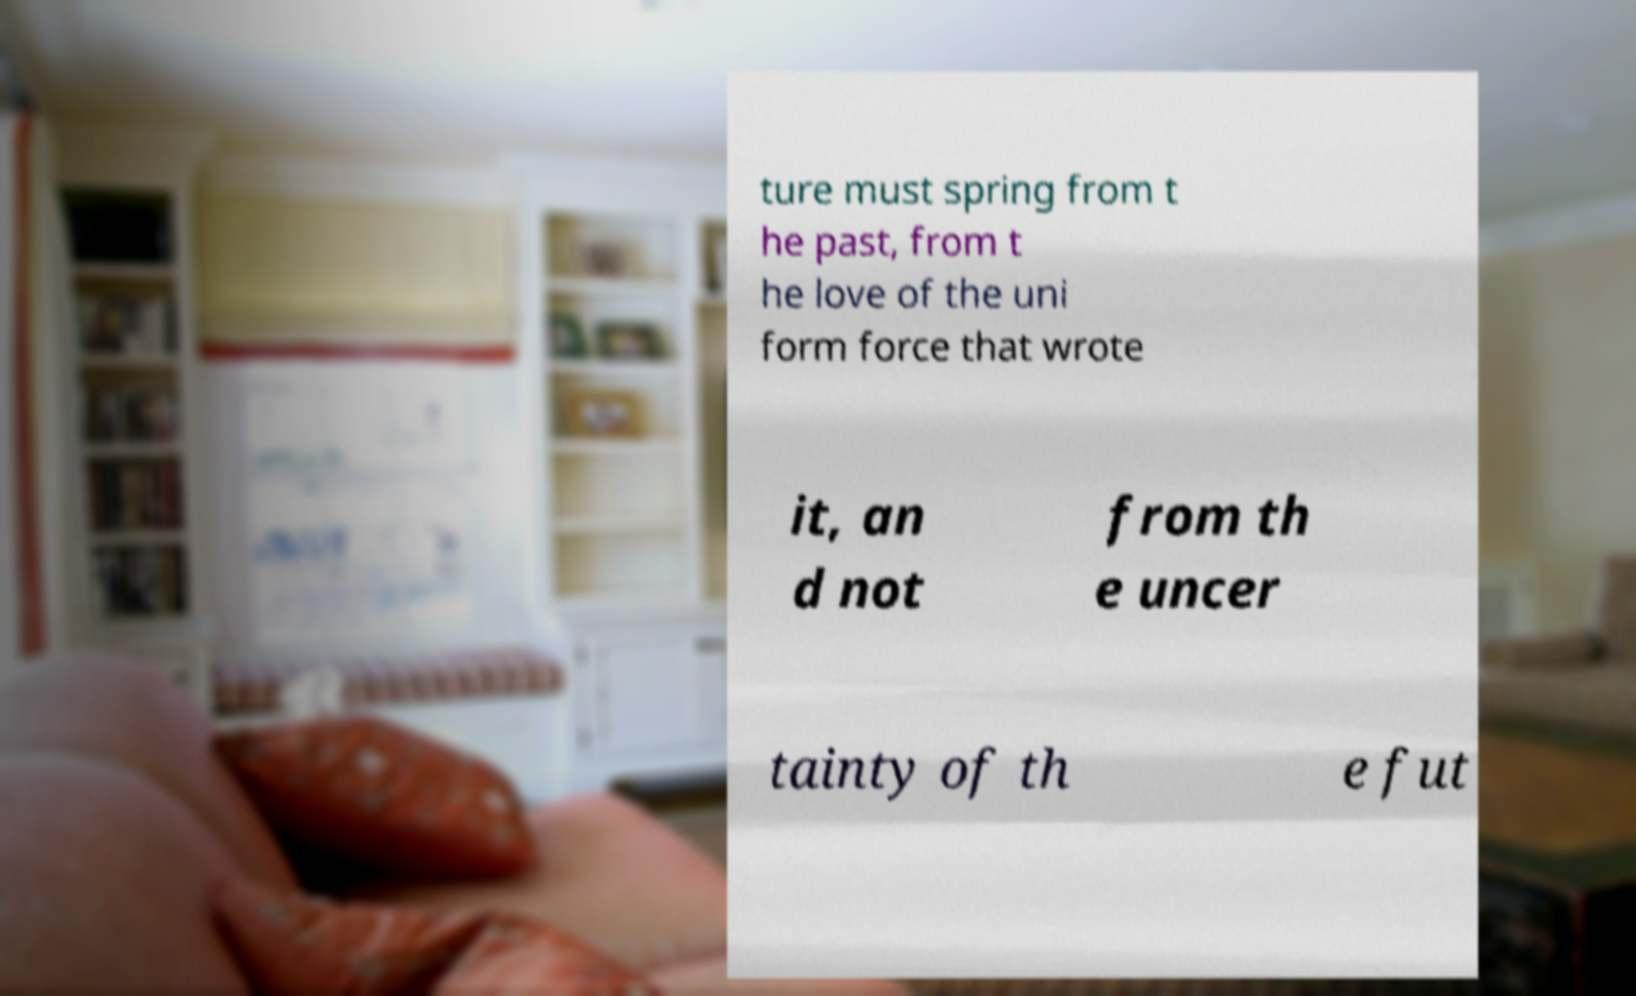Please read and relay the text visible in this image. What does it say? ture must spring from t he past, from t he love of the uni form force that wrote it, an d not from th e uncer tainty of th e fut 